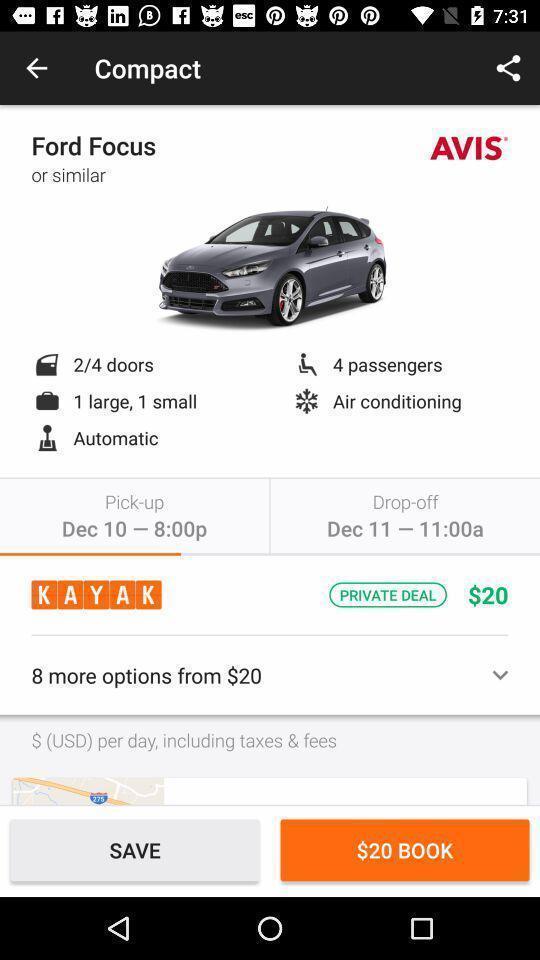Summarize the main components in this picture. Page to book a rent car. 